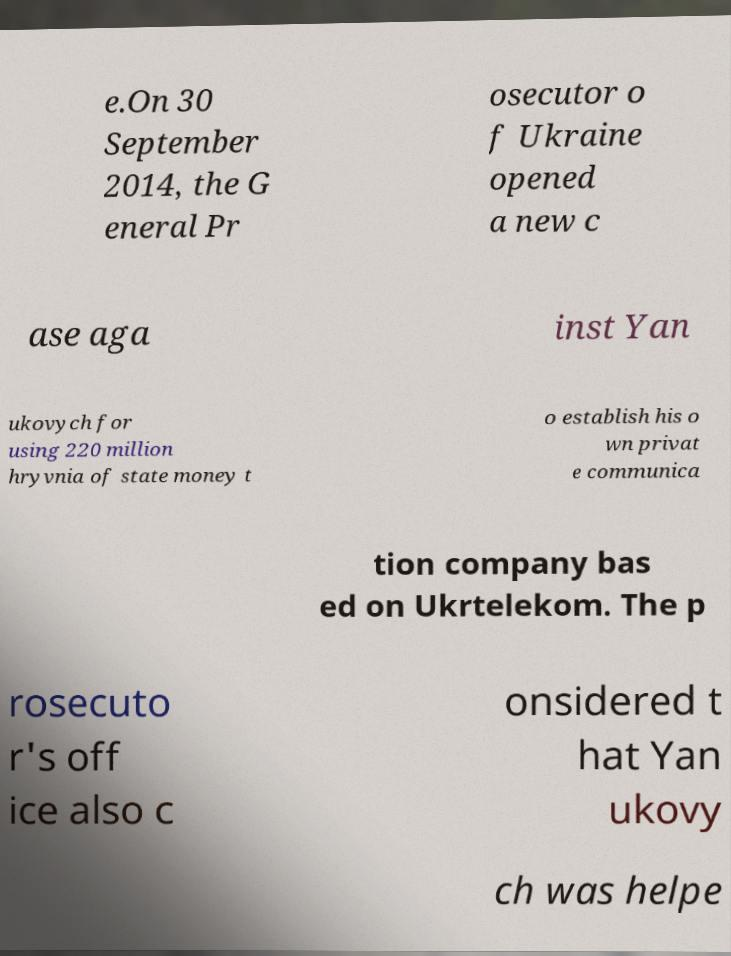For documentation purposes, I need the text within this image transcribed. Could you provide that? e.On 30 September 2014, the G eneral Pr osecutor o f Ukraine opened a new c ase aga inst Yan ukovych for using 220 million hryvnia of state money t o establish his o wn privat e communica tion company bas ed on Ukrtelekom. The p rosecuto r's off ice also c onsidered t hat Yan ukovy ch was helpe 